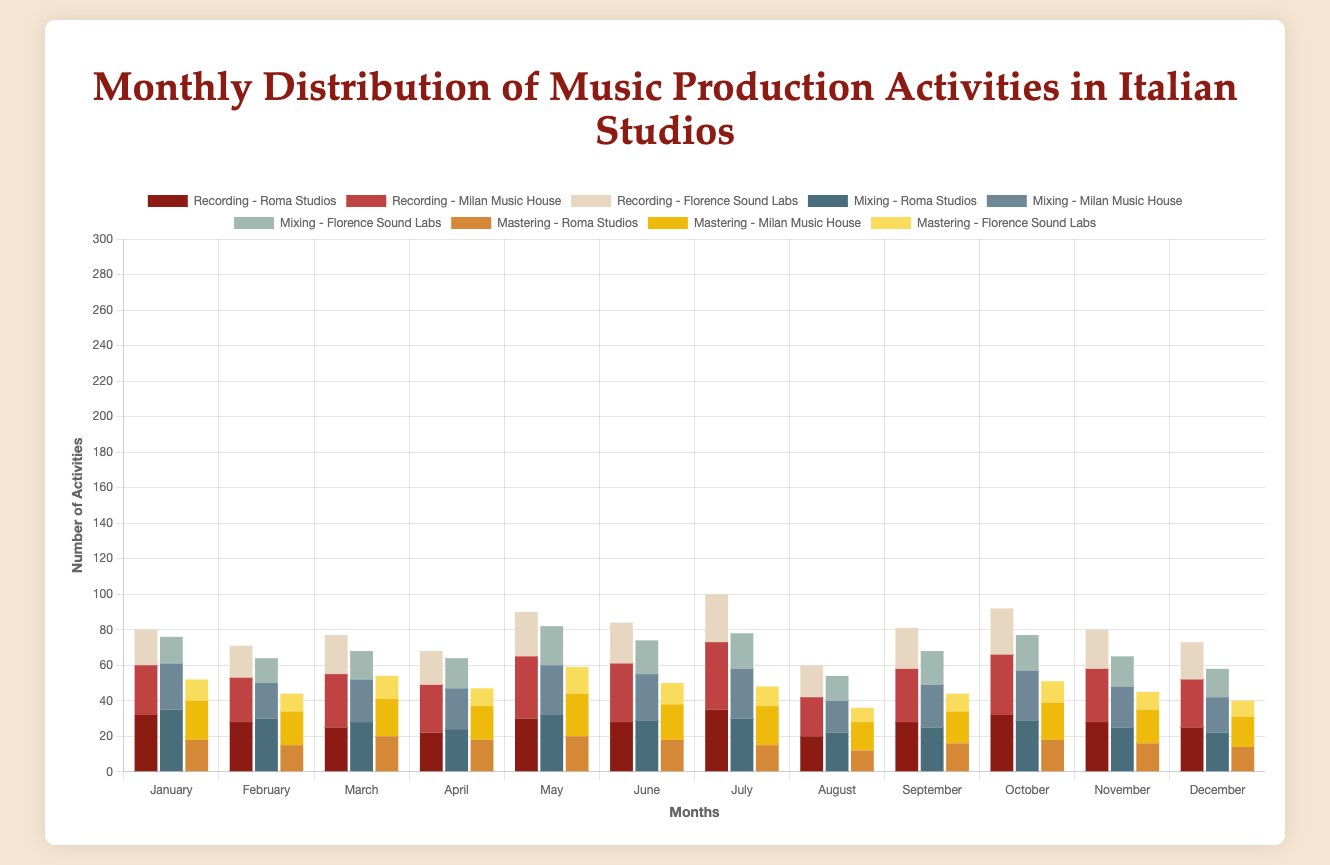Which studio had the highest total number of Recording activities in January? To find this, refer to the January Recording data. Roma Studios had 32, Milan Music House had 28, and Florence Sound Labs had 20. Roma Studios has the highest number.
Answer: Roma Studios Comparing July and August, in which month did Milan Music House have more Mixing activities? Check the data for Mixing activities in July and August. Milan Music House had 28 Mixing activities in July and 18 in August. July had more Mixing activities.
Answer: July What is the total number of Mastering activities carried out by all studios in March? Summing up Mastering activities in March for all studios: Roma Studios (20) + Milan Music House (21) + Florence Sound Labs (13) equals 54.
Answer: 54 How does the number of Recording activities at Florence Sound Labs in May compare to June? Recording activities for Florence Sound Labs in May (25) and in June (23) show that May has more Recording activities by a difference of 2.
Answer: May (2 more) Which activity (Recording, Mixing, or Mastering) had the least number of activities in April across all studios? Summing up all activities in April: Recording (22 + 27 + 19 = 68), Mixing (24 + 23 + 17 = 64), Mastering (18 + 19 + 10 = 47). Mastering had the least with 47 activities.
Answer: Mastering What is the average number of Mixing activities in December for all studios? Adding the Mixing activities for December (Roma Studios 22, Milan Music House 20, Florence Sound Labs 16), the sum is 58. Dividing by the number of studios (3), the average is 58/3 = 19.33.
Answer: 19.33 During which month did Roma Studios conduct the highest number of Recording activities? Checking each month's data for Roma Studios: January (32), February (28), March (25), April (22), May (30), June (28), July (35), August (20), September (28), October (32), November (28), December (25). July had the highest with 35 activities.
Answer: July If we sum the number of Mixing and Mastering activities at Milan Music House for June, what is the total? Milan Music House had 26 Mixing activities and 20 Mastering activities in June. Summing them, we get 26 + 20 = 46.
Answer: 46 Which studio has the most consistent (smallest range) number of Recording activities across the year? Calculate the range for each studio: 
Roma Studios (35 - 20 = 15), Milan Music House (38 - 22 = 16), Florence Sound Labs (27 - 18 = 9). Florence Sound Labs has the smallest range (9).
Answer: Florence Sound Labs 